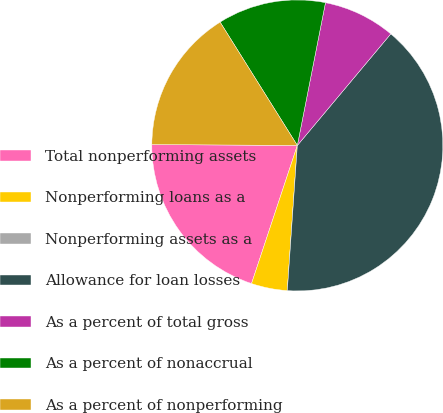Convert chart. <chart><loc_0><loc_0><loc_500><loc_500><pie_chart><fcel>Total nonperforming assets<fcel>Nonperforming loans as a<fcel>Nonperforming assets as a<fcel>Allowance for loan losses<fcel>As a percent of total gross<fcel>As a percent of nonaccrual<fcel>As a percent of nonperforming<nl><fcel>20.0%<fcel>4.0%<fcel>0.0%<fcel>40.0%<fcel>8.0%<fcel>12.0%<fcel>16.0%<nl></chart> 